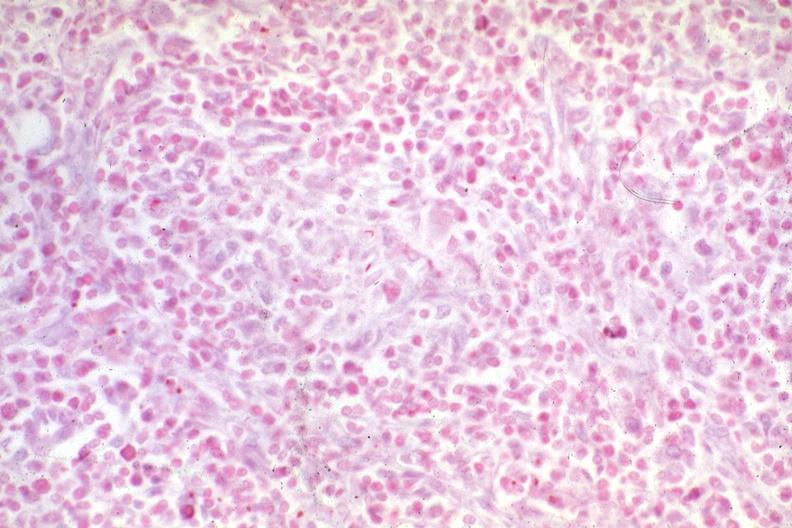does this image show acid fast hemophiliac with aids typical?
Answer the question using a single word or phrase. Yes 